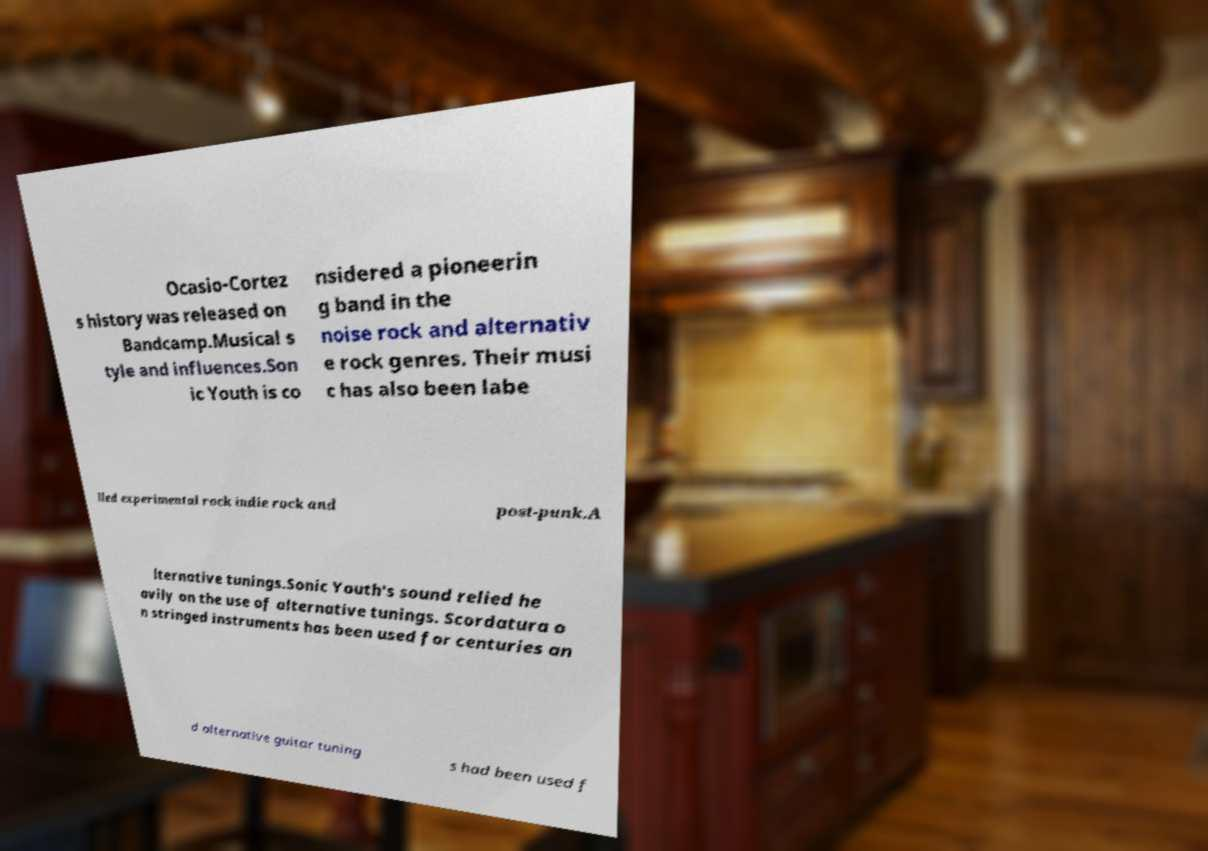Could you assist in decoding the text presented in this image and type it out clearly? Ocasio-Cortez s history was released on Bandcamp.Musical s tyle and influences.Son ic Youth is co nsidered a pioneerin g band in the noise rock and alternativ e rock genres. Their musi c has also been labe lled experimental rock indie rock and post-punk.A lternative tunings.Sonic Youth's sound relied he avily on the use of alternative tunings. Scordatura o n stringed instruments has been used for centuries an d alternative guitar tuning s had been used f 